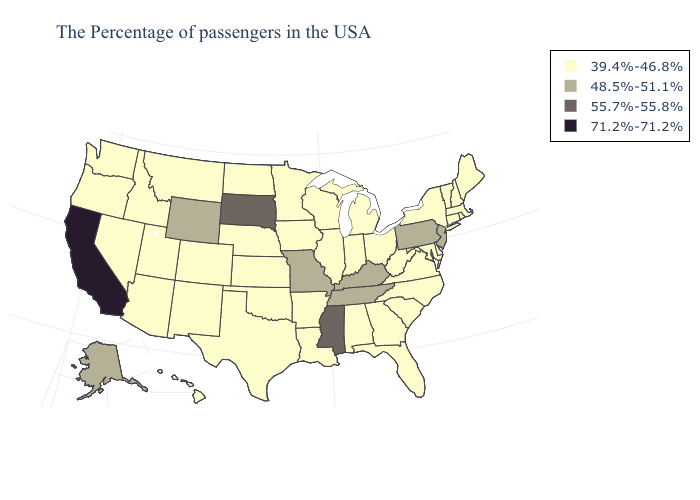Which states have the lowest value in the West?
Short answer required. Colorado, New Mexico, Utah, Montana, Arizona, Idaho, Nevada, Washington, Oregon, Hawaii. Is the legend a continuous bar?
Answer briefly. No. Does North Dakota have a higher value than Louisiana?
Quick response, please. No. Name the states that have a value in the range 71.2%-71.2%?
Short answer required. California. What is the lowest value in the Northeast?
Short answer required. 39.4%-46.8%. What is the value of Utah?
Answer briefly. 39.4%-46.8%. What is the value of Maine?
Answer briefly. 39.4%-46.8%. Name the states that have a value in the range 55.7%-55.8%?
Give a very brief answer. Mississippi, South Dakota. Does the first symbol in the legend represent the smallest category?
Give a very brief answer. Yes. What is the value of South Carolina?
Answer briefly. 39.4%-46.8%. Name the states that have a value in the range 39.4%-46.8%?
Keep it brief. Maine, Massachusetts, Rhode Island, New Hampshire, Vermont, Connecticut, New York, Delaware, Maryland, Virginia, North Carolina, South Carolina, West Virginia, Ohio, Florida, Georgia, Michigan, Indiana, Alabama, Wisconsin, Illinois, Louisiana, Arkansas, Minnesota, Iowa, Kansas, Nebraska, Oklahoma, Texas, North Dakota, Colorado, New Mexico, Utah, Montana, Arizona, Idaho, Nevada, Washington, Oregon, Hawaii. What is the value of New Mexico?
Be succinct. 39.4%-46.8%. Which states have the highest value in the USA?
Concise answer only. California. Does Tennessee have the lowest value in the South?
Quick response, please. No. What is the lowest value in the MidWest?
Write a very short answer. 39.4%-46.8%. 